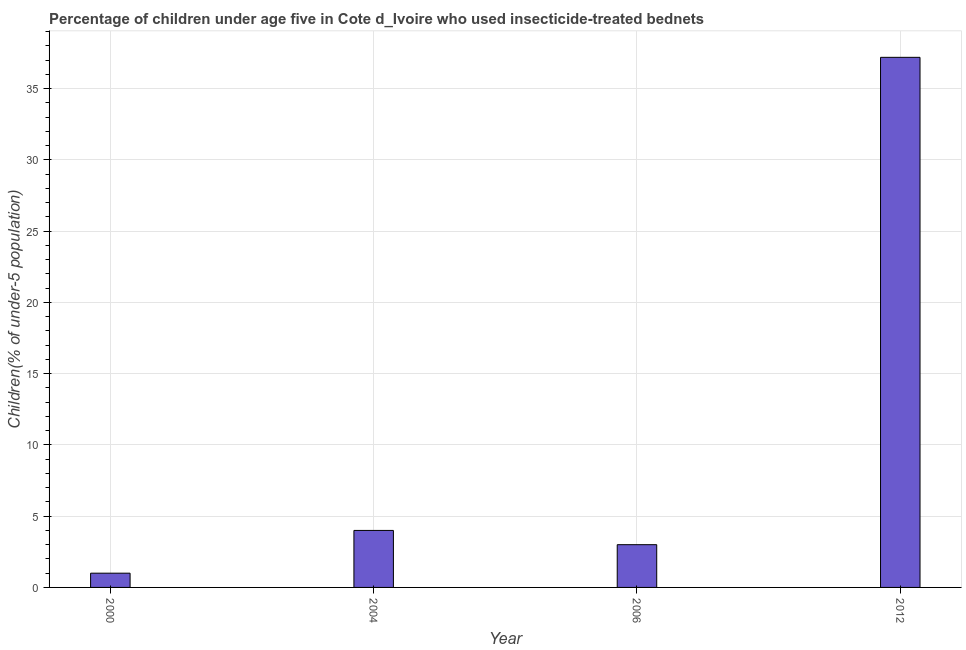Does the graph contain grids?
Ensure brevity in your answer.  Yes. What is the title of the graph?
Your answer should be compact. Percentage of children under age five in Cote d_Ivoire who used insecticide-treated bednets. What is the label or title of the Y-axis?
Offer a very short reply. Children(% of under-5 population). What is the percentage of children who use of insecticide-treated bed nets in 2012?
Give a very brief answer. 37.2. Across all years, what is the maximum percentage of children who use of insecticide-treated bed nets?
Your answer should be very brief. 37.2. Across all years, what is the minimum percentage of children who use of insecticide-treated bed nets?
Give a very brief answer. 1. In which year was the percentage of children who use of insecticide-treated bed nets maximum?
Provide a succinct answer. 2012. In which year was the percentage of children who use of insecticide-treated bed nets minimum?
Your response must be concise. 2000. What is the sum of the percentage of children who use of insecticide-treated bed nets?
Your answer should be compact. 45.2. What is the difference between the percentage of children who use of insecticide-treated bed nets in 2000 and 2012?
Make the answer very short. -36.2. What is the median percentage of children who use of insecticide-treated bed nets?
Your answer should be very brief. 3.5. In how many years, is the percentage of children who use of insecticide-treated bed nets greater than 11 %?
Offer a very short reply. 1. What is the ratio of the percentage of children who use of insecticide-treated bed nets in 2006 to that in 2012?
Offer a terse response. 0.08. What is the difference between the highest and the second highest percentage of children who use of insecticide-treated bed nets?
Offer a very short reply. 33.2. What is the difference between the highest and the lowest percentage of children who use of insecticide-treated bed nets?
Ensure brevity in your answer.  36.2. In how many years, is the percentage of children who use of insecticide-treated bed nets greater than the average percentage of children who use of insecticide-treated bed nets taken over all years?
Ensure brevity in your answer.  1. How many bars are there?
Your response must be concise. 4. Are all the bars in the graph horizontal?
Your answer should be compact. No. What is the difference between two consecutive major ticks on the Y-axis?
Make the answer very short. 5. What is the Children(% of under-5 population) in 2000?
Make the answer very short. 1. What is the Children(% of under-5 population) in 2006?
Your answer should be very brief. 3. What is the Children(% of under-5 population) in 2012?
Offer a terse response. 37.2. What is the difference between the Children(% of under-5 population) in 2000 and 2006?
Your response must be concise. -2. What is the difference between the Children(% of under-5 population) in 2000 and 2012?
Provide a short and direct response. -36.2. What is the difference between the Children(% of under-5 population) in 2004 and 2006?
Your answer should be very brief. 1. What is the difference between the Children(% of under-5 population) in 2004 and 2012?
Provide a succinct answer. -33.2. What is the difference between the Children(% of under-5 population) in 2006 and 2012?
Provide a short and direct response. -34.2. What is the ratio of the Children(% of under-5 population) in 2000 to that in 2004?
Make the answer very short. 0.25. What is the ratio of the Children(% of under-5 population) in 2000 to that in 2006?
Your answer should be very brief. 0.33. What is the ratio of the Children(% of under-5 population) in 2000 to that in 2012?
Make the answer very short. 0.03. What is the ratio of the Children(% of under-5 population) in 2004 to that in 2006?
Give a very brief answer. 1.33. What is the ratio of the Children(% of under-5 population) in 2004 to that in 2012?
Offer a terse response. 0.11. What is the ratio of the Children(% of under-5 population) in 2006 to that in 2012?
Your answer should be compact. 0.08. 